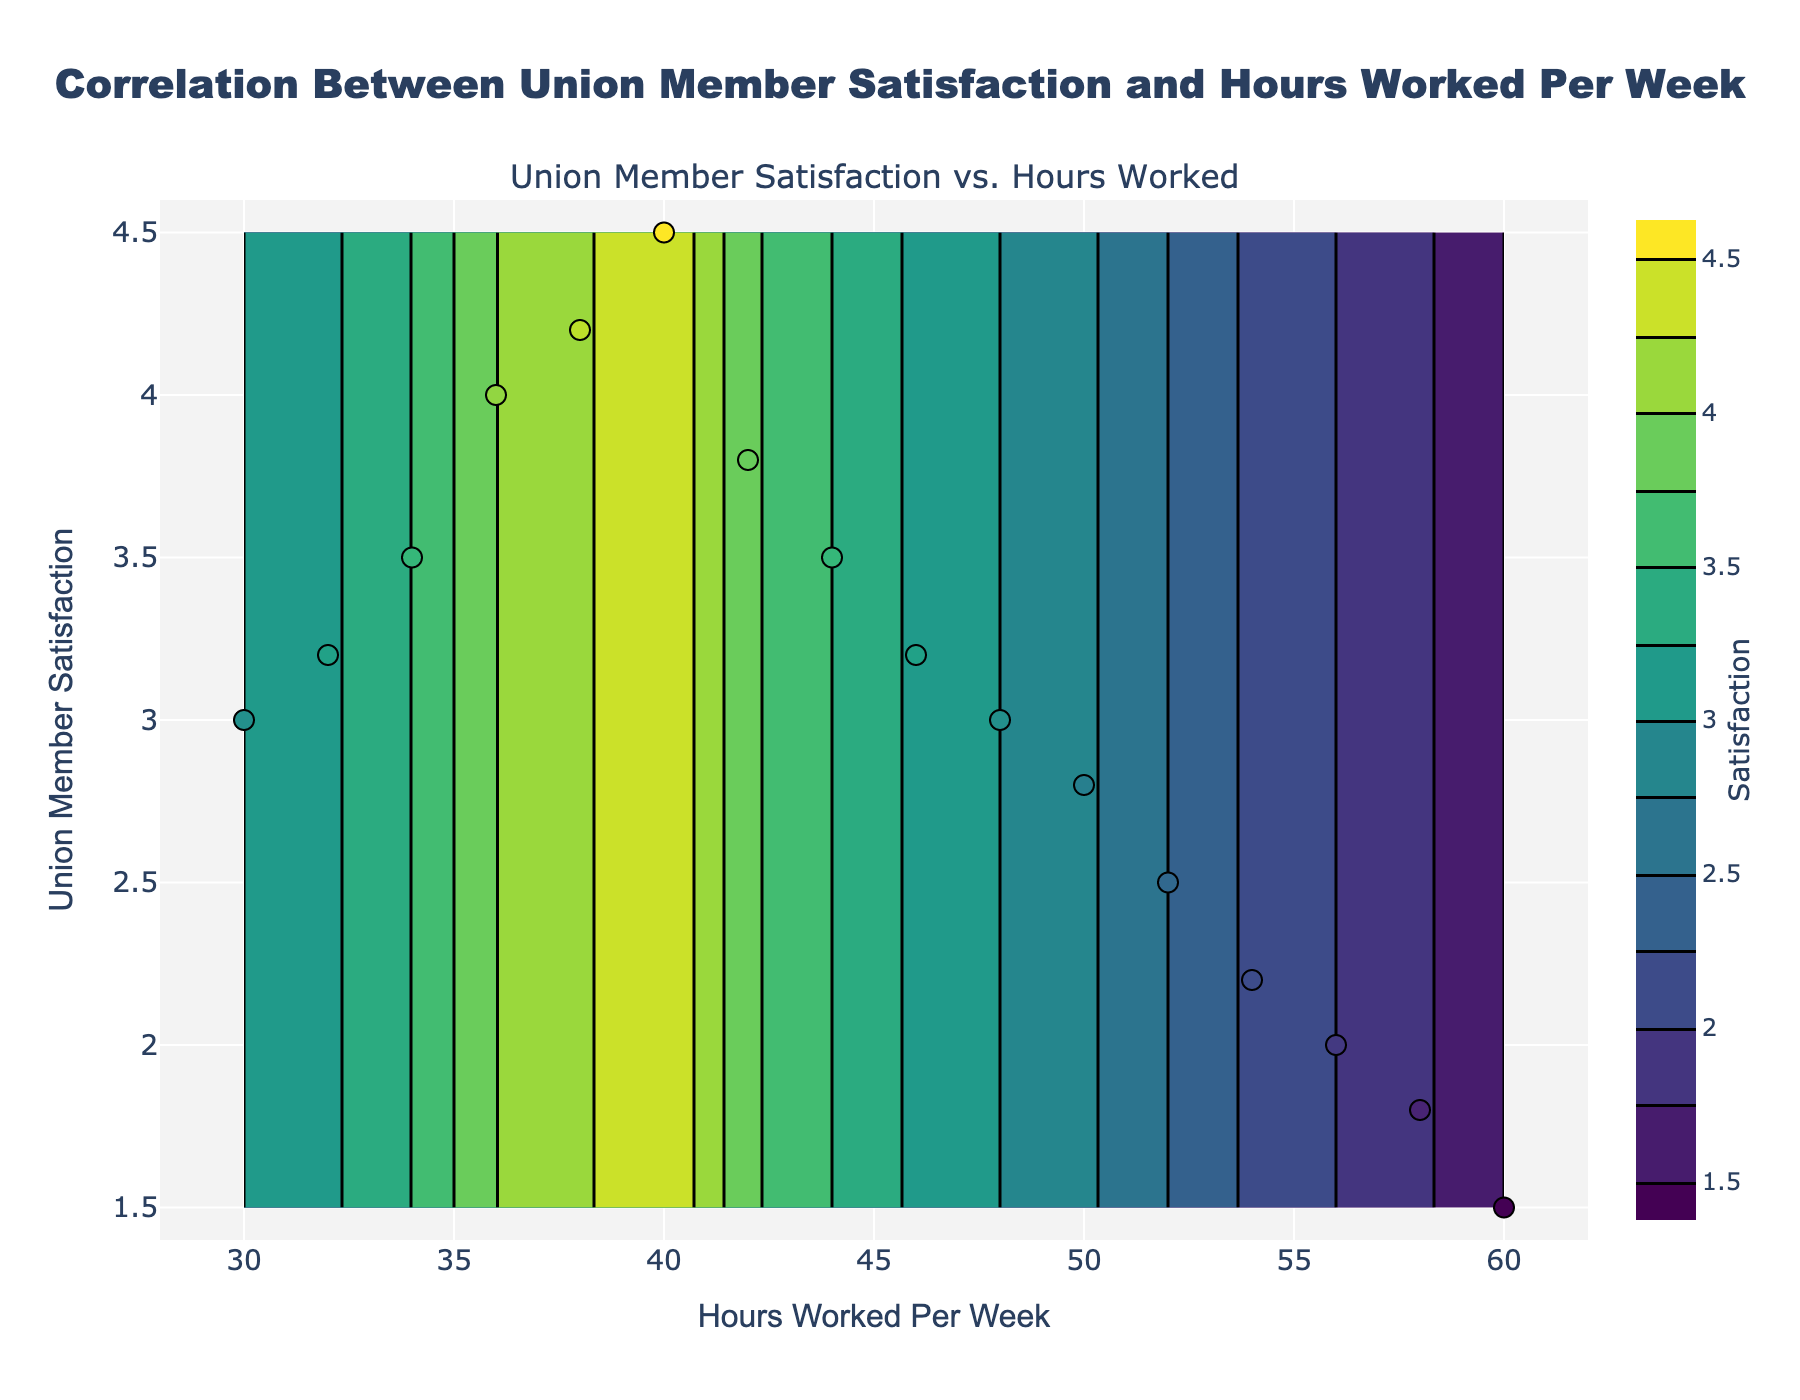what is the title of the figure? The title of the figure is located at the top center and is written in a larger font.
Answer: Correlation Between Union Member Satisfaction and Hours Worked Per Week What is the x-axis label? The x-axis label is located below the horizontal axis.
Answer: Hours Worked Per Week How many data points are shown in the scatter plot? The scatter plot shows one data point for each row in the dataset, which has 16 rows.
Answer: 16 What's the color scale used for the contour plot? The contour plot uses a color gradient from green to yellow.
Answer: Viridis What's the range of the x-axis? The range of the x-axis can be observed by looking at the minimum and maximum ticks on the horizontal axis.
Answer: 28 to 62 What is the range of union member satisfaction values in the dataset? The y-axis label "Union Member Satisfaction" and the associated ticks on the y-axis provide the satisfaction values' range.
Answer: 1.5 to 4.5 At approximately how many hours worked per week is union member satisfaction at its lowest value? Observing the scatter points and the contour color gradient, the lowest levels of satisfaction (darker color) are around 60 hours.
Answer: 60 What is the approximate union member satisfaction level at 40 hours worked per week? Looking at the scatter plot, union member satisfaction at 40 hours worked per week is represented by one of the scatter points.
Answer: 4.5 Which interval of hours worked per week shows a declining trend in union member satisfaction? Observing the scatter points from left to right (30 to 60 hours), satisfaction first rises and then declines significantly past 40 hours worked per week.
Answer: 42-60 hours How are the contour lines spaced and what does that tell us about the rate of change in satisfaction? The contour lines' spacing reflects the rate at which satisfaction changes; closely spaced lines indicate rapid change while widely spaced lines indicate gradual change.
Answer: Rapidly changing before 40 hours and gradually after 